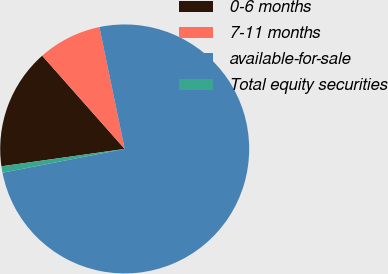Convert chart to OTSL. <chart><loc_0><loc_0><loc_500><loc_500><pie_chart><fcel>0-6 months<fcel>7-11 months<fcel>available-for-sale<fcel>Total equity securities<nl><fcel>15.7%<fcel>8.27%<fcel>75.2%<fcel>0.83%<nl></chart> 